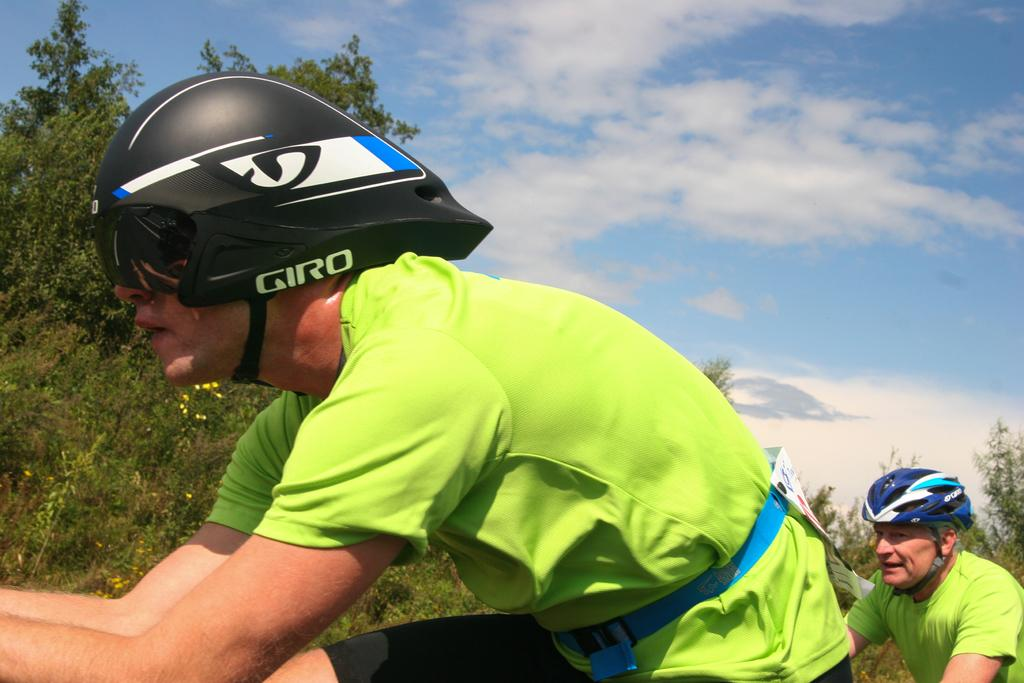How many men are in the foreground of the image? There are two men in the foreground of the image. What are the men wearing on their upper bodies? Both men are wearing green T-shirts. What type of headgear are the men wearing? Both men are wearing helmets. Can you describe the man with a poster in the foreground? There is a man in the foreground with a poster at his waist. What can be seen in the background of the image? There are trees and the sky visible in the background of the image. What is the condition of the sky in the image? The sky is visible in the background of the image, and there are clouds present. What is the average income of the group in the image? There is no information about income in the image, as it only shows two men wearing green T-shirts, helmets, and a man with a poster in the foreground. 